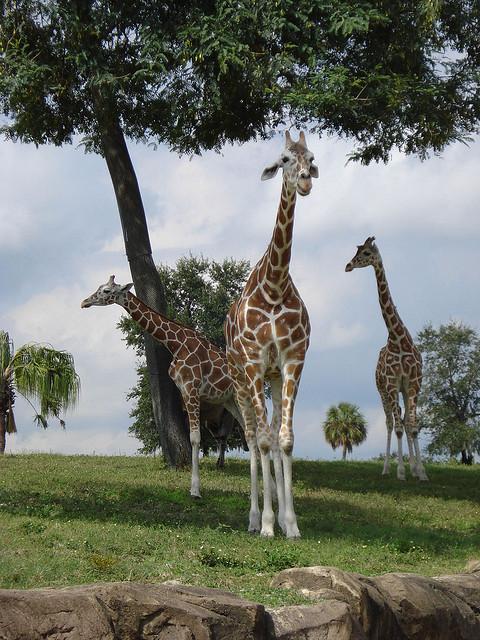Might this animal feel lonely?
Keep it brief. No. What continent is this animal from?
Short answer required. Africa. What kind of animals are in the images?
Give a very brief answer. Giraffe. What continent would this animal not be indigenous to?
Give a very brief answer. North america. How many giraffe  are there in the picture?
Be succinct. 3. Where is the giraffe?
Answer briefly. Under tree. How many animals are shown?
Give a very brief answer. 3. Is this giraffe behind a fence?
Quick response, please. No. 